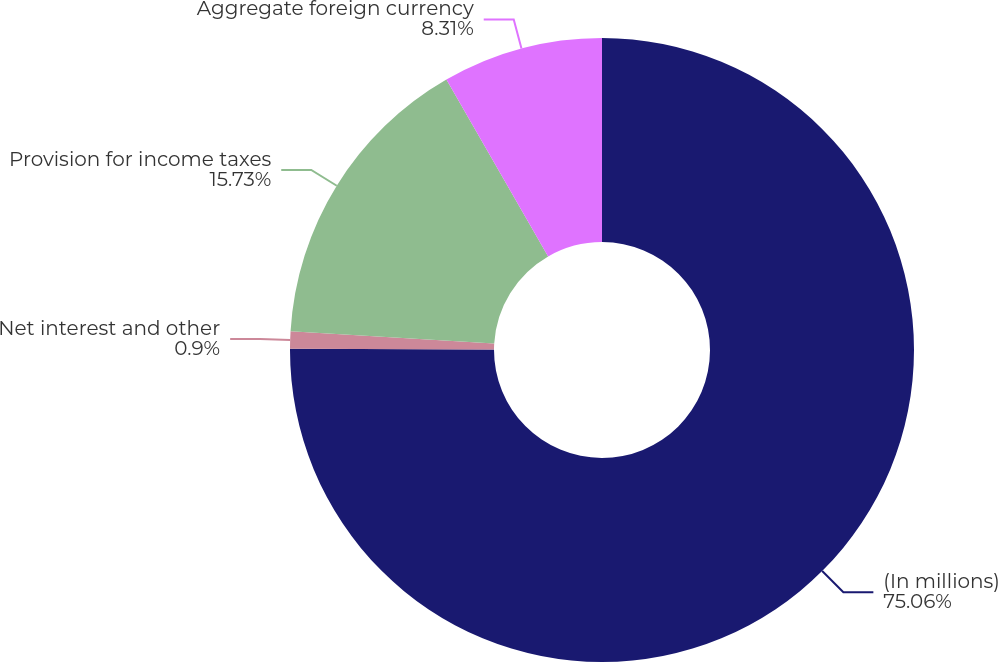Convert chart. <chart><loc_0><loc_0><loc_500><loc_500><pie_chart><fcel>(In millions)<fcel>Net interest and other<fcel>Provision for income taxes<fcel>Aggregate foreign currency<nl><fcel>75.06%<fcel>0.9%<fcel>15.73%<fcel>8.31%<nl></chart> 